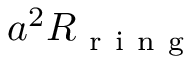Convert formula to latex. <formula><loc_0><loc_0><loc_500><loc_500>a ^ { 2 } R _ { r i n g }</formula> 